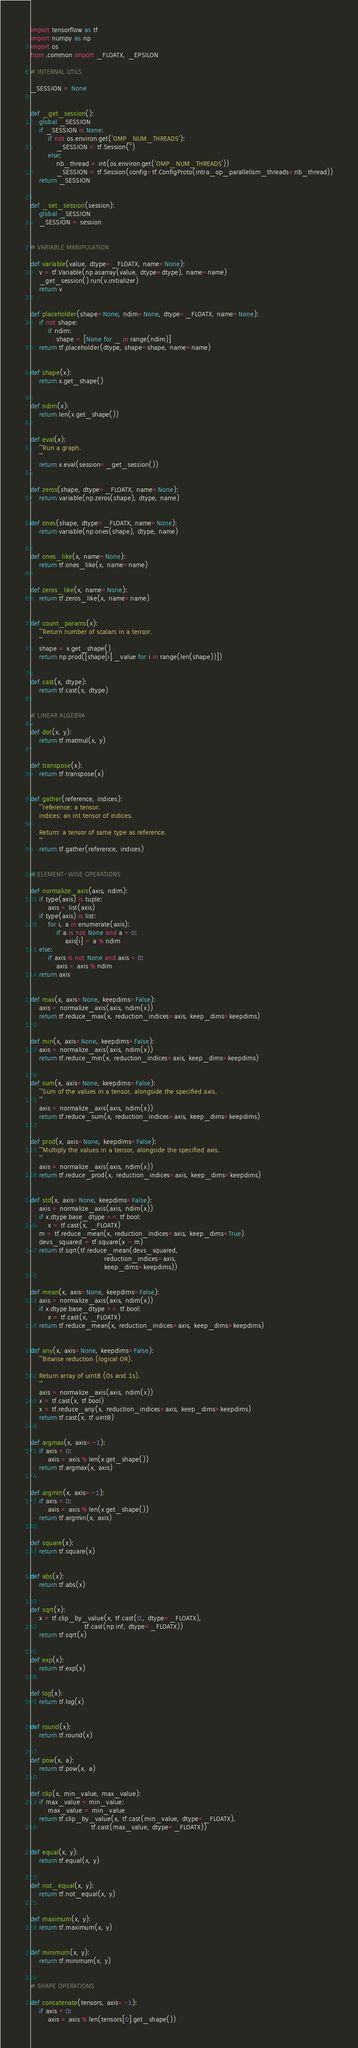Convert code to text. <code><loc_0><loc_0><loc_500><loc_500><_Python_>import tensorflow as tf
import numpy as np
import os
from .common import _FLOATX, _EPSILON

# INTERNAL UTILS

_SESSION = None


def _get_session():
    global _SESSION
    if _SESSION is None:
        if not os.environ.get('OMP_NUM_THREADS'):
            _SESSION = tf.Session('')
        else:
            nb_thread = int(os.environ.get('OMP_NUM_THREADS'))
            _SESSION = tf.Session(config=tf.ConfigProto(intra_op_parallelism_threads=nb_thread))
    return _SESSION


def _set_session(session):
    global _SESSION
    _SESSION = session


# VARIABLE MANIPULATION

def variable(value, dtype=_FLOATX, name=None):
    v = tf.Variable(np.asarray(value, dtype=dtype), name=name)
    _get_session().run(v.initializer)
    return v


def placeholder(shape=None, ndim=None, dtype=_FLOATX, name=None):
    if not shape:
        if ndim:
            shape = [None for _ in range(ndim)]
    return tf.placeholder(dtype, shape=shape, name=name)


def shape(x):
    return x.get_shape()


def ndim(x):
    return len(x.get_shape())


def eval(x):
    '''Run a graph.
    '''
    return x.eval(session=_get_session())


def zeros(shape, dtype=_FLOATX, name=None):
    return variable(np.zeros(shape), dtype, name)


def ones(shape, dtype=_FLOATX, name=None):
    return variable(np.ones(shape), dtype, name)


def ones_like(x, name=None):
    return tf.ones_like(x, name=name)


def zeros_like(x, name=None):
    return tf.zeros_like(x, name=name)


def count_params(x):
    '''Return number of scalars in a tensor.
    '''
    shape = x.get_shape()
    return np.prod([shape[i]._value for i in range(len(shape))])


def cast(x, dtype):
    return tf.cast(x, dtype)


# LINEAR ALGEBRA

def dot(x, y):
    return tf.matmul(x, y)


def transpose(x):
    return tf.transpose(x)


def gather(reference, indices):
    '''reference: a tensor.
    indices: an int tensor of indices.

    Return: a tensor of same type as reference.
    '''
    return tf.gather(reference, indices)


# ELEMENT-WISE OPERATIONS

def normalize_axis(axis, ndim):
    if type(axis) is tuple:
        axis = list(axis)
    if type(axis) is list:
        for i, a in enumerate(axis):
            if a is not None and a < 0:
                axis[i] = a % ndim
    else:
        if axis is not None and axis < 0:
            axis = axis % ndim
    return axis


def max(x, axis=None, keepdims=False):
    axis = normalize_axis(axis, ndim(x))
    return tf.reduce_max(x, reduction_indices=axis, keep_dims=keepdims)


def min(x, axis=None, keepdims=False):
    axis = normalize_axis(axis, ndim(x))
    return tf.reduce_min(x, reduction_indices=axis, keep_dims=keepdims)


def sum(x, axis=None, keepdims=False):
    '''Sum of the values in a tensor, alongside the specified axis.
    '''
    axis = normalize_axis(axis, ndim(x))
    return tf.reduce_sum(x, reduction_indices=axis, keep_dims=keepdims)


def prod(x, axis=None, keepdims=False):
    '''Multiply the values in a tensor, alongside the specified axis.
    '''
    axis = normalize_axis(axis, ndim(x))
    return tf.reduce_prod(x, reduction_indices=axis, keep_dims=keepdims)


def std(x, axis=None, keepdims=False):
    axis = normalize_axis(axis, ndim(x))
    if x.dtype.base_dtype == tf.bool:
        x = tf.cast(x, _FLOATX)
    m = tf.reduce_mean(x, reduction_indices=axis, keep_dims=True)
    devs_squared = tf.square(x - m)
    return tf.sqrt(tf.reduce_mean(devs_squared,
                                  reduction_indices=axis,
                                  keep_dims=keepdims))


def mean(x, axis=None, keepdims=False):
    axis = normalize_axis(axis, ndim(x))
    if x.dtype.base_dtype == tf.bool:
        x = tf.cast(x, _FLOATX)
    return tf.reduce_mean(x, reduction_indices=axis, keep_dims=keepdims)


def any(x, axis=None, keepdims=False):
    '''Bitwise reduction (logical OR).

    Return array of uint8 (0s and 1s).
    '''
    axis = normalize_axis(axis, ndim(x))
    x = tf.cast(x, tf.bool)
    x = tf.reduce_any(x, reduction_indices=axis, keep_dims=keepdims)
    return tf.cast(x, tf.uint8)


def argmax(x, axis=-1):
    if axis < 0:
        axis = axis % len(x.get_shape())
    return tf.argmax(x, axis)


def argmin(x, axis=-1):
    if axis < 0:
        axis = axis % len(x.get_shape())
    return tf.argmin(x, axis)


def square(x):
    return tf.square(x)


def abs(x):
    return tf.abs(x)


def sqrt(x):
    x = tf.clip_by_value(x, tf.cast(0., dtype=_FLOATX),
                         tf.cast(np.inf, dtype=_FLOATX))
    return tf.sqrt(x)


def exp(x):
    return tf.exp(x)


def log(x):
    return tf.log(x)


def round(x):
    return tf.round(x)


def pow(x, a):
    return tf.pow(x, a)


def clip(x, min_value, max_value):
    if max_value < min_value:
        max_value = min_value
    return tf.clip_by_value(x, tf.cast(min_value, dtype=_FLOATX),
                            tf.cast(max_value, dtype=_FLOATX))


def equal(x, y):
    return tf.equal(x, y)


def not_equal(x, y):
    return tf.not_equal(x, y)


def maximum(x, y):
    return tf.maximum(x, y)


def minimum(x, y):
    return tf.minimum(x, y)


# SHAPE OPERATIONS

def concatenate(tensors, axis=-1):
    if axis < 0:
        axis = axis % len(tensors[0].get_shape())</code> 